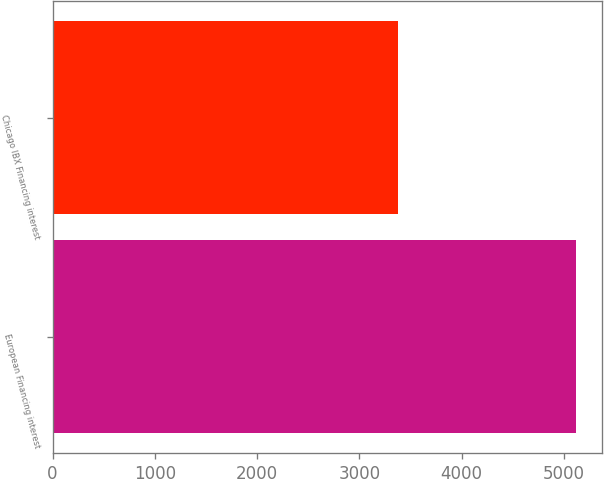Convert chart to OTSL. <chart><loc_0><loc_0><loc_500><loc_500><bar_chart><fcel>European Financing interest<fcel>Chicago IBX Financing interest<nl><fcel>5117<fcel>3379<nl></chart> 